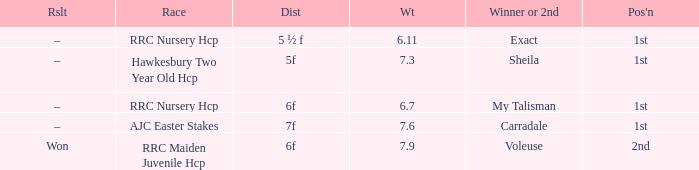What is the the name of the winner or 2nd  with a weight more than 7.3, and the result was –? Carradale. 